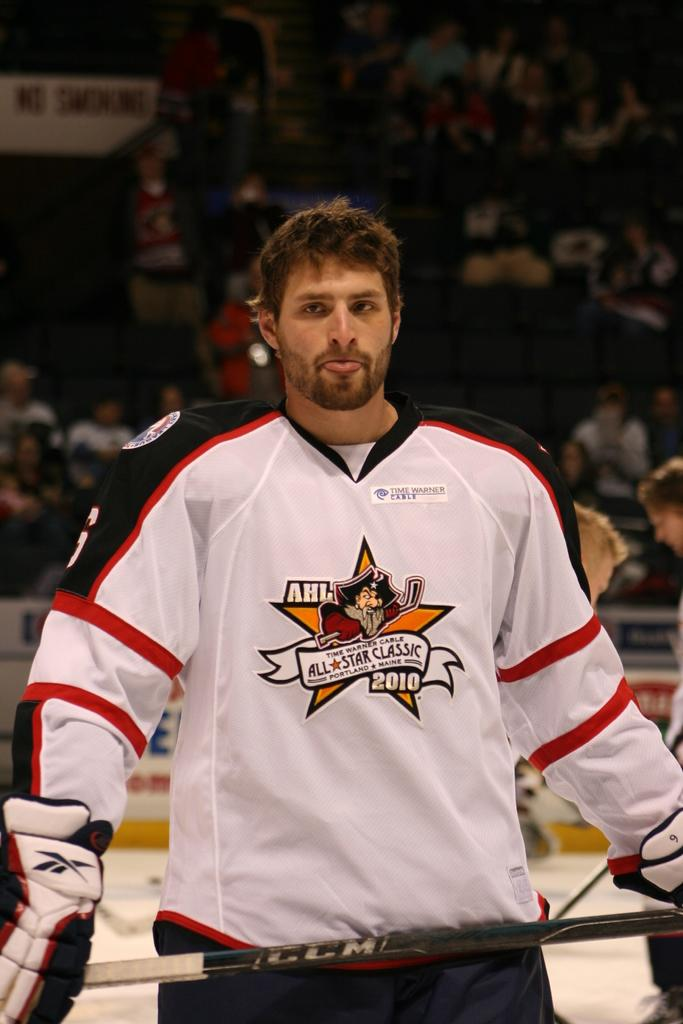<image>
Share a concise interpretation of the image provided. a person in an AHL jersey on the ice 